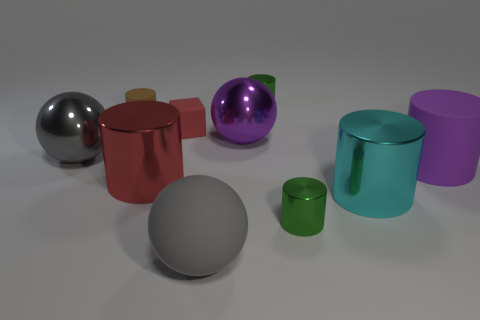There is a large thing that is the same color as the rubber block; what is it made of?
Your response must be concise. Metal. Do the tiny matte cube and the big shiny cylinder that is to the left of the large purple shiny ball have the same color?
Give a very brief answer. Yes. What number of objects are either things or brown shiny things?
Provide a succinct answer. 10. What is the material of the purple cylinder that is the same size as the red metal object?
Provide a succinct answer. Rubber. There is a matte cylinder behind the big purple rubber object; what size is it?
Keep it short and to the point. Small. What is the large cyan object made of?
Your response must be concise. Metal. How many objects are small red rubber things that are on the right side of the big gray shiny object or big things that are to the right of the matte cube?
Ensure brevity in your answer.  5. How many other things are the same color as the rubber ball?
Keep it short and to the point. 1. There is a purple rubber object; is it the same shape as the tiny green metallic object that is behind the brown cylinder?
Keep it short and to the point. Yes. Is the number of small brown rubber objects in front of the big red cylinder less than the number of cyan cylinders on the left side of the big cyan object?
Make the answer very short. No. 